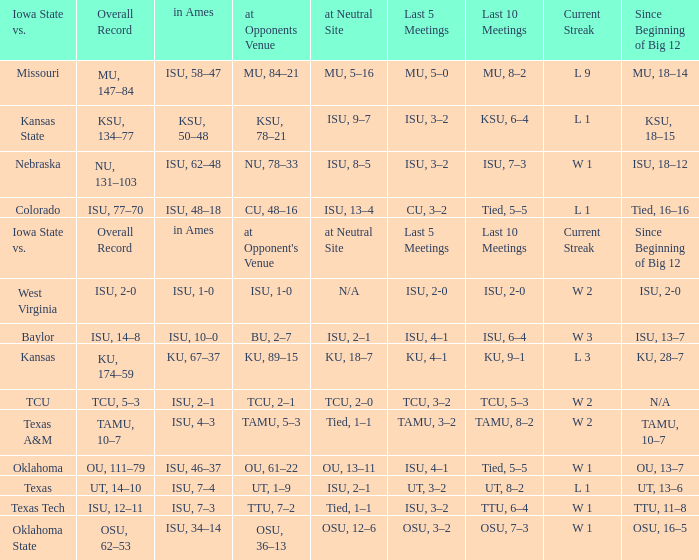When the value of "since beginning of big 12" is synonymous with its' category, what are the in Ames values? In ames. 